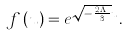Convert formula to latex. <formula><loc_0><loc_0><loc_500><loc_500>f \left ( u \right ) = e ^ { \sqrt { - \frac { 2 \varepsilon \Lambda } { 3 } } u } .</formula> 